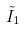<formula> <loc_0><loc_0><loc_500><loc_500>\tilde { I } _ { 1 }</formula> 